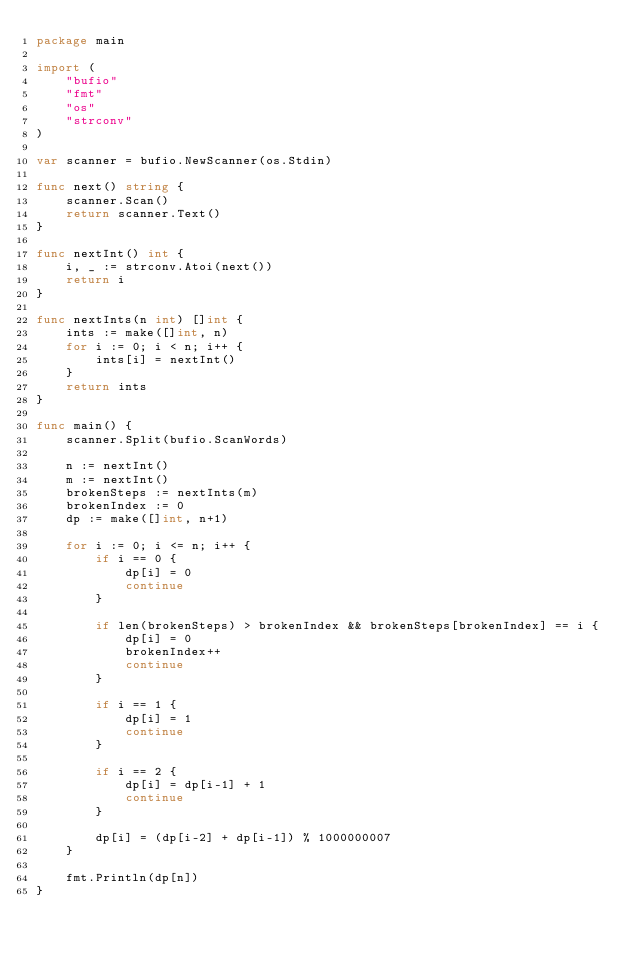Convert code to text. <code><loc_0><loc_0><loc_500><loc_500><_Go_>package main

import (
	"bufio"
	"fmt"
	"os"
	"strconv"
)

var scanner = bufio.NewScanner(os.Stdin)

func next() string {
	scanner.Scan()
	return scanner.Text()
}

func nextInt() int {
	i, _ := strconv.Atoi(next())
	return i
}

func nextInts(n int) []int {
	ints := make([]int, n)
	for i := 0; i < n; i++ {
		ints[i] = nextInt()
	}
	return ints
}

func main() {
	scanner.Split(bufio.ScanWords)

	n := nextInt()
	m := nextInt()
	brokenSteps := nextInts(m)
	brokenIndex := 0
	dp := make([]int, n+1)

	for i := 0; i <= n; i++ {
		if i == 0 {
			dp[i] = 0
			continue
		}

		if len(brokenSteps) > brokenIndex && brokenSteps[brokenIndex] == i {
			dp[i] = 0
			brokenIndex++
			continue
		}

		if i == 1 {
			dp[i] = 1
			continue
		}

		if i == 2 {
			dp[i] = dp[i-1] + 1
			continue
		}

		dp[i] = (dp[i-2] + dp[i-1]) % 1000000007
	}

	fmt.Println(dp[n])
}
</code> 